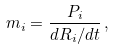<formula> <loc_0><loc_0><loc_500><loc_500>m _ { i } = \frac { P _ { i } } { d R _ { i } / d t } \, ,</formula> 